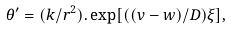Convert formula to latex. <formula><loc_0><loc_0><loc_500><loc_500>\theta ^ { \prime } = ( k / r ^ { 2 } ) . \exp [ ( ( v - w ) / D ) \xi ] ,</formula> 